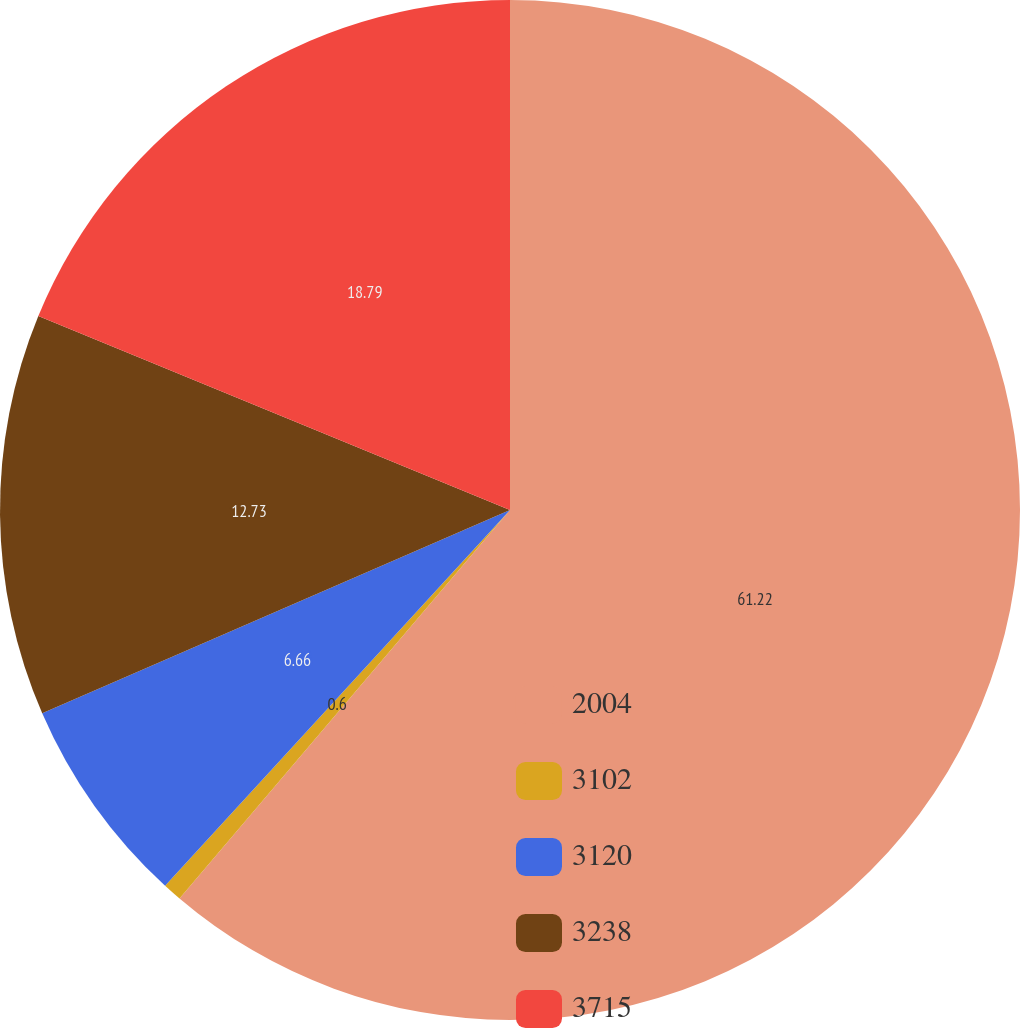Convert chart. <chart><loc_0><loc_0><loc_500><loc_500><pie_chart><fcel>2004<fcel>3102<fcel>3120<fcel>3238<fcel>3715<nl><fcel>61.22%<fcel>0.6%<fcel>6.66%<fcel>12.73%<fcel>18.79%<nl></chart> 